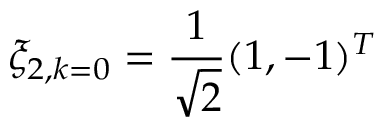Convert formula to latex. <formula><loc_0><loc_0><loc_500><loc_500>\xi _ { 2 , k = 0 } = \frac { 1 } { \sqrt { 2 } } ( 1 , - 1 ) ^ { T }</formula> 